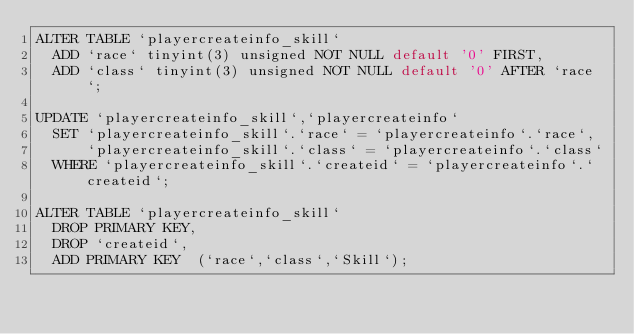Convert code to text. <code><loc_0><loc_0><loc_500><loc_500><_SQL_>ALTER TABLE `playercreateinfo_skill`
  ADD `race` tinyint(3) unsigned NOT NULL default '0' FIRST,
  ADD `class` tinyint(3) unsigned NOT NULL default '0' AFTER `race`;

UPDATE `playercreateinfo_skill`,`playercreateinfo`
  SET `playercreateinfo_skill`.`race` = `playercreateinfo`.`race`,
      `playercreateinfo_skill`.`class` = `playercreateinfo`.`class`
  WHERE `playercreateinfo_skill`.`createid` = `playercreateinfo`.`createid`;

ALTER TABLE `playercreateinfo_skill`
  DROP PRIMARY KEY,
  DROP `createid`,
  ADD PRIMARY KEY  (`race`,`class`,`Skill`);

</code> 